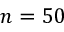<formula> <loc_0><loc_0><loc_500><loc_500>n = 5 0</formula> 